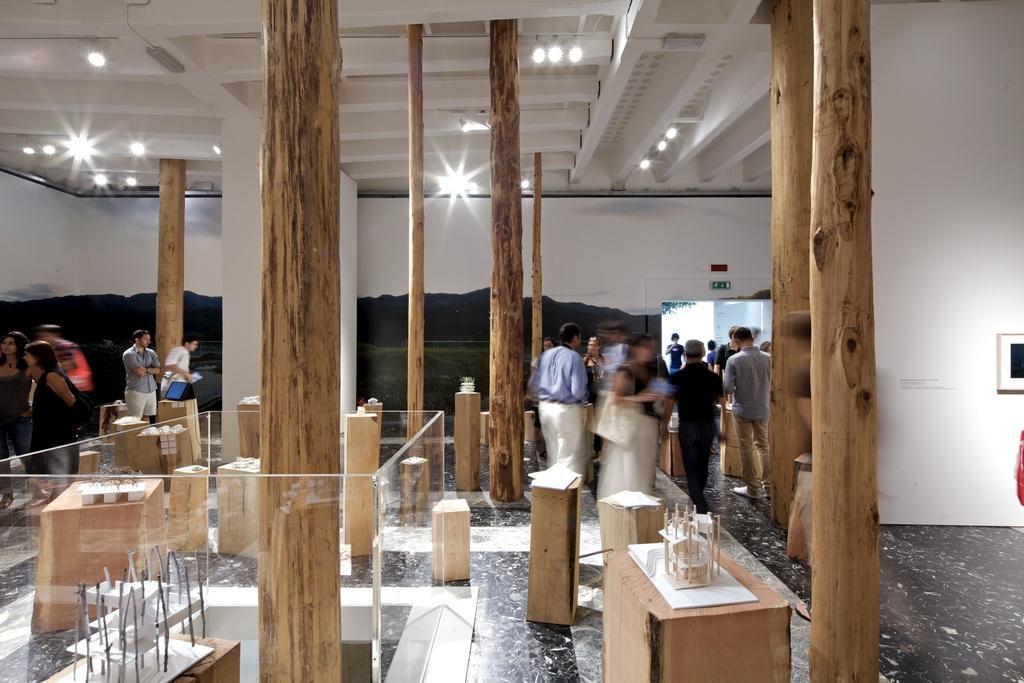In one or two sentences, can you explain what this image depicts? In this picture there are people on the right and left side of the image, it seems to be plywood stock in the image. 